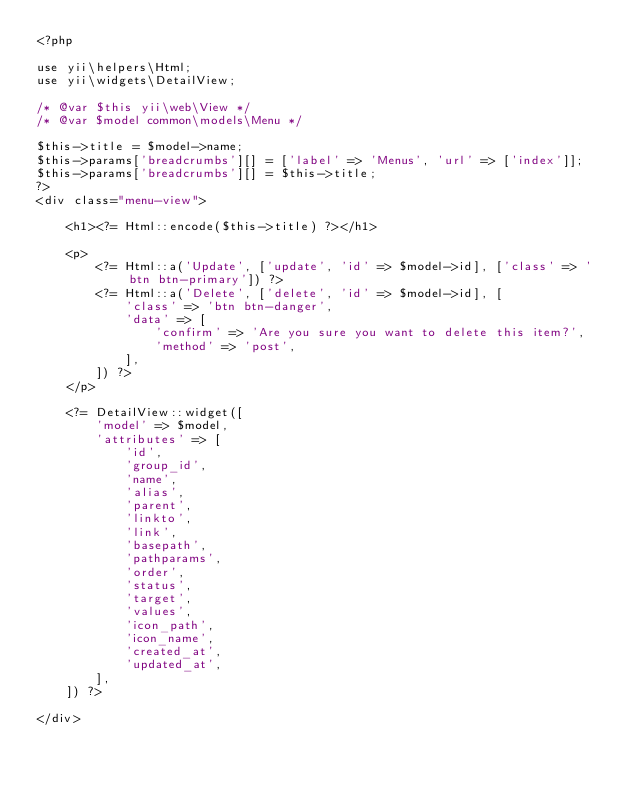Convert code to text. <code><loc_0><loc_0><loc_500><loc_500><_PHP_><?php

use yii\helpers\Html;
use yii\widgets\DetailView;

/* @var $this yii\web\View */
/* @var $model common\models\Menu */

$this->title = $model->name;
$this->params['breadcrumbs'][] = ['label' => 'Menus', 'url' => ['index']];
$this->params['breadcrumbs'][] = $this->title;
?>
<div class="menu-view">

    <h1><?= Html::encode($this->title) ?></h1>

    <p>
        <?= Html::a('Update', ['update', 'id' => $model->id], ['class' => 'btn btn-primary']) ?>
        <?= Html::a('Delete', ['delete', 'id' => $model->id], [
            'class' => 'btn btn-danger',
            'data' => [
                'confirm' => 'Are you sure you want to delete this item?',
                'method' => 'post',
            ],
        ]) ?>
    </p>

    <?= DetailView::widget([
        'model' => $model,
        'attributes' => [
            'id',
            'group_id',
            'name',
            'alias',
            'parent',
            'linkto',
            'link',
            'basepath',
            'pathparams',
            'order',
            'status',
            'target',
            'values',
            'icon_path',
            'icon_name',
            'created_at',
            'updated_at',
        ],
    ]) ?>

</div>
</code> 